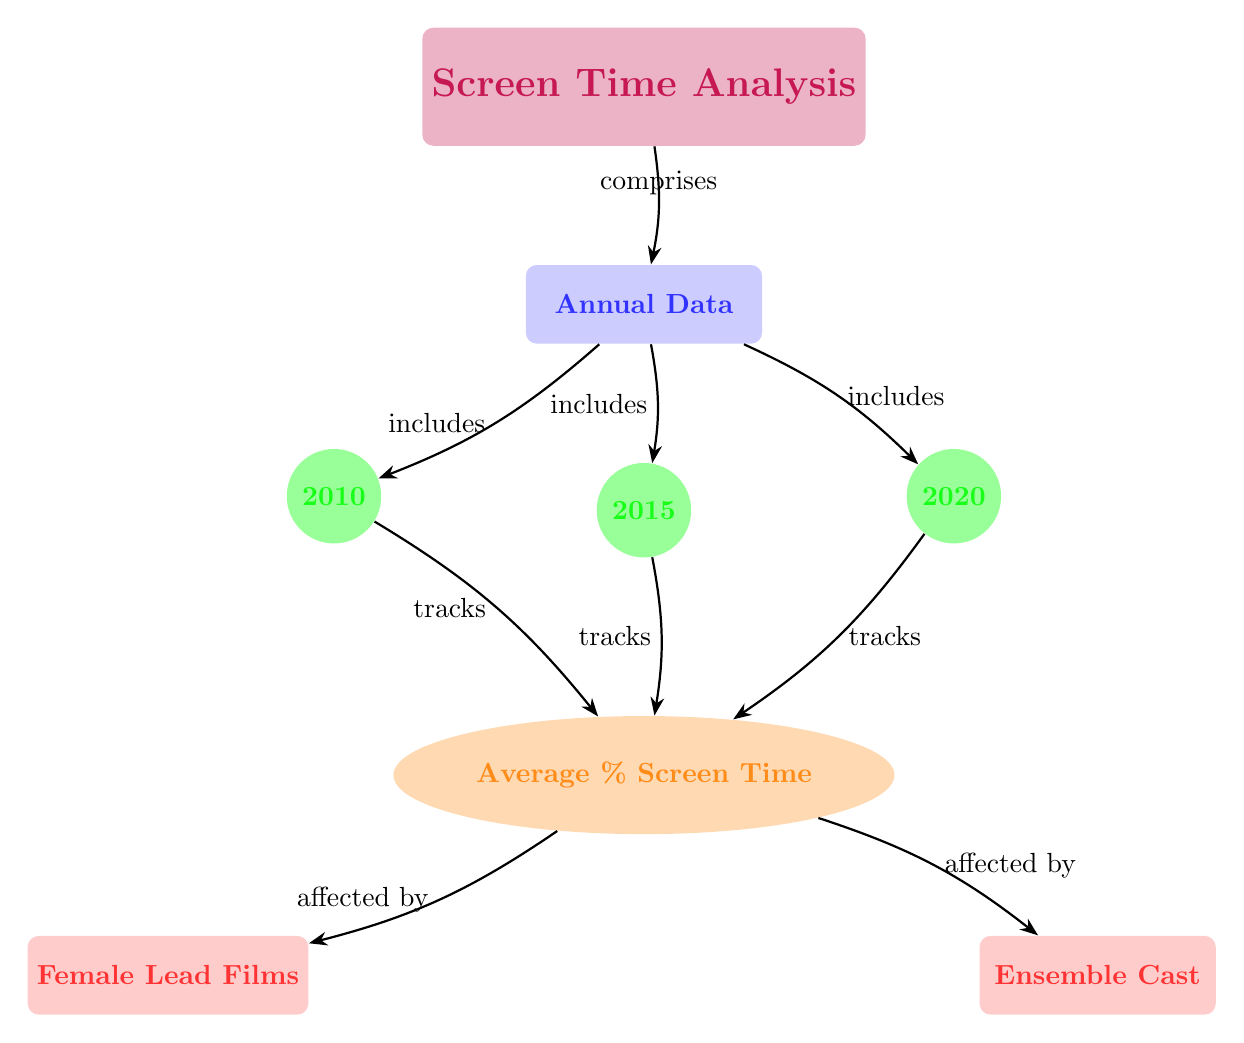What is the general theme of the diagram? The diagram represents the analysis of screen time for female characters in top grossing films over specific years, which addresses gender representation in cinema.
Answer: Screen Time Analysis How many years are included in the annual data of the diagram? The diagram includes three years: 2010, 2015, and 2020, as indicated by the year nodes under the annual data category.
Answer: Three What do the female lead films impact? The female lead films impact the average percentage of screen time for female characters, as shown by the edge connecting the lead node to the average node.
Answer: Average percentage of screen time How does the average percentage of screen time relate to ensemble cast films? The average percentage of screen time is affected by ensemble cast films, which is explicitly stated in the diagram through an edge connecting the ensemble node to the average node.
Answer: Affected by What type of data is represented at the average percentage node? The average percentage node represents numerical data that indicates the average percentage of screen time for female characters in films.
Answer: Numerical data What relationship exists between 2015 and the average screen time? The relationship is that the year 2015 tracks the average percentage of screen time for female characters, as indicated by the connecting edge in the diagram.
Answer: Tracks Which components make up the main category of the diagram? The main category of the diagram comprises the annual data, which incorporates the three years and their respective average percentages.
Answer: Annual Data What does the average percentage of screen time depend on? The average percentage of screen time depends on both female lead films and ensemble cast films as shown by the edges leading to the average node.
Answer: Female Lead Films and Ensemble Cast What kind of visual representation is used for the never-ending gender representation discussion? The visual representation is a flowchart that illustrates relationships and dependencies between various elements of screen time and films in a structured manner.
Answer: Flowchart 